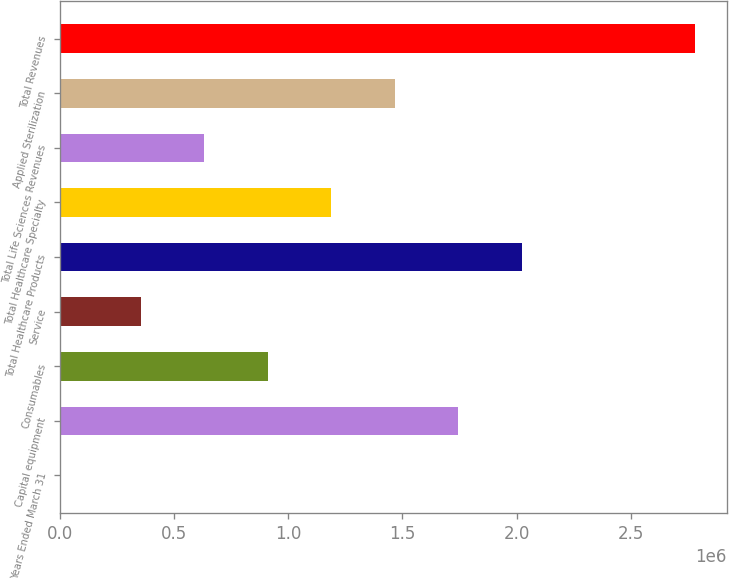Convert chart. <chart><loc_0><loc_0><loc_500><loc_500><bar_chart><fcel>Years Ended March 31<fcel>Capital equipment<fcel>Consumables<fcel>Service<fcel>Total Healthcare Products<fcel>Total Healthcare Specialty<fcel>Total Life Sciences Revenues<fcel>Applied Sterilization<fcel>Total Revenues<nl><fcel>2019<fcel>1.74472e+06<fcel>910678<fcel>354648<fcel>2.02274e+06<fcel>1.18869e+06<fcel>632663<fcel>1.46671e+06<fcel>2.78217e+06<nl></chart> 